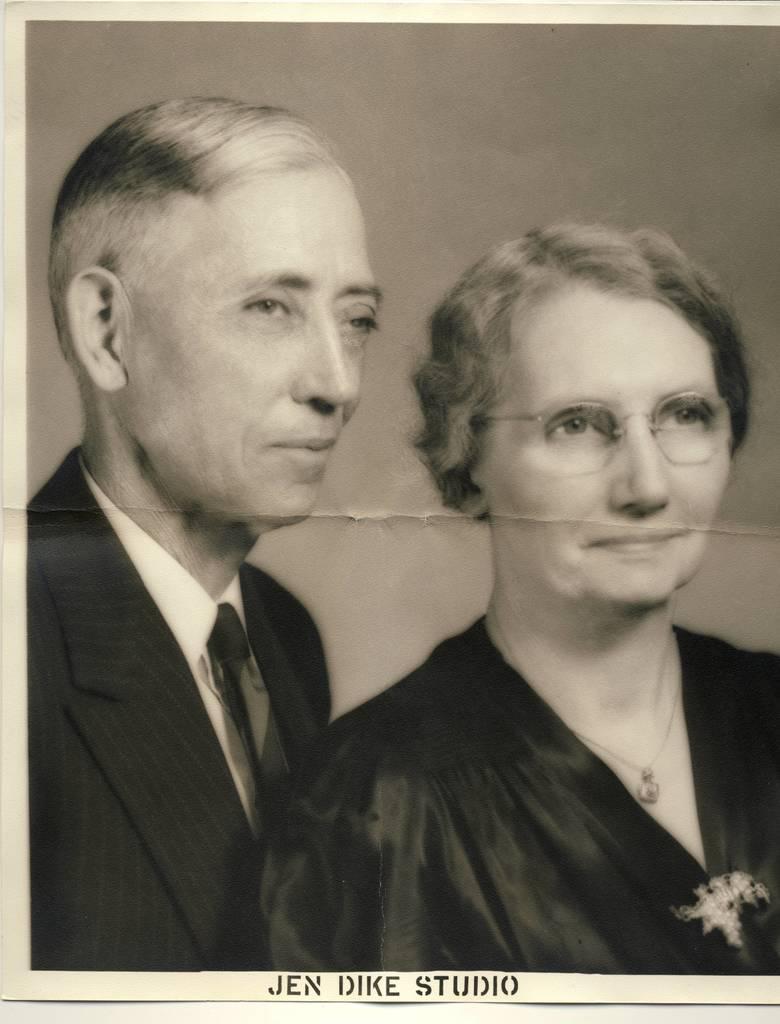Please provide a concise description of this image. This is a black and white poster, we can see two persons on the poster and at the bottom of the poster we can see some text. 